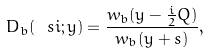Convert formula to latex. <formula><loc_0><loc_0><loc_500><loc_500>D _ { b } ( \ s i ; y ) = \frac { w _ { b } ( y - \frac { i } { 2 } Q ) } { w _ { b } ( y + s ) } ,</formula> 